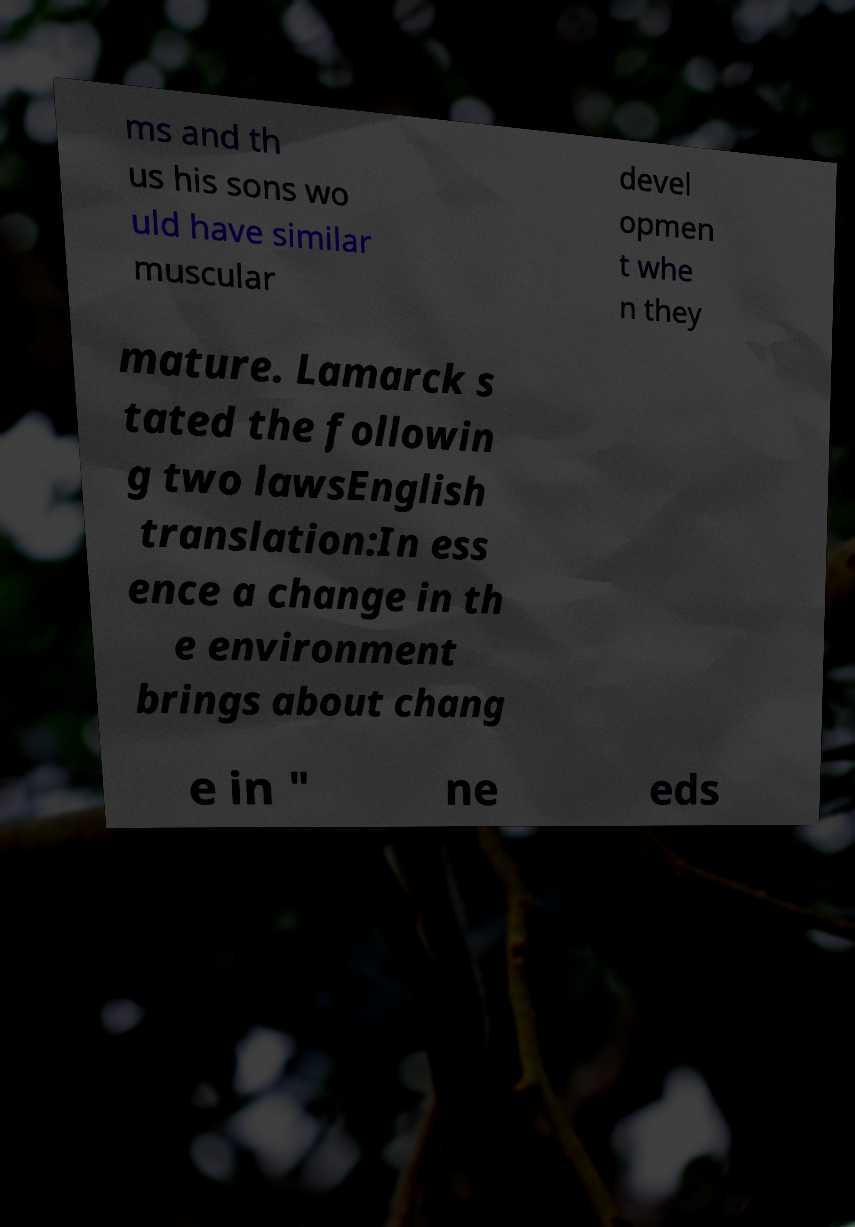Can you accurately transcribe the text from the provided image for me? ms and th us his sons wo uld have similar muscular devel opmen t whe n they mature. Lamarck s tated the followin g two lawsEnglish translation:In ess ence a change in th e environment brings about chang e in " ne eds 